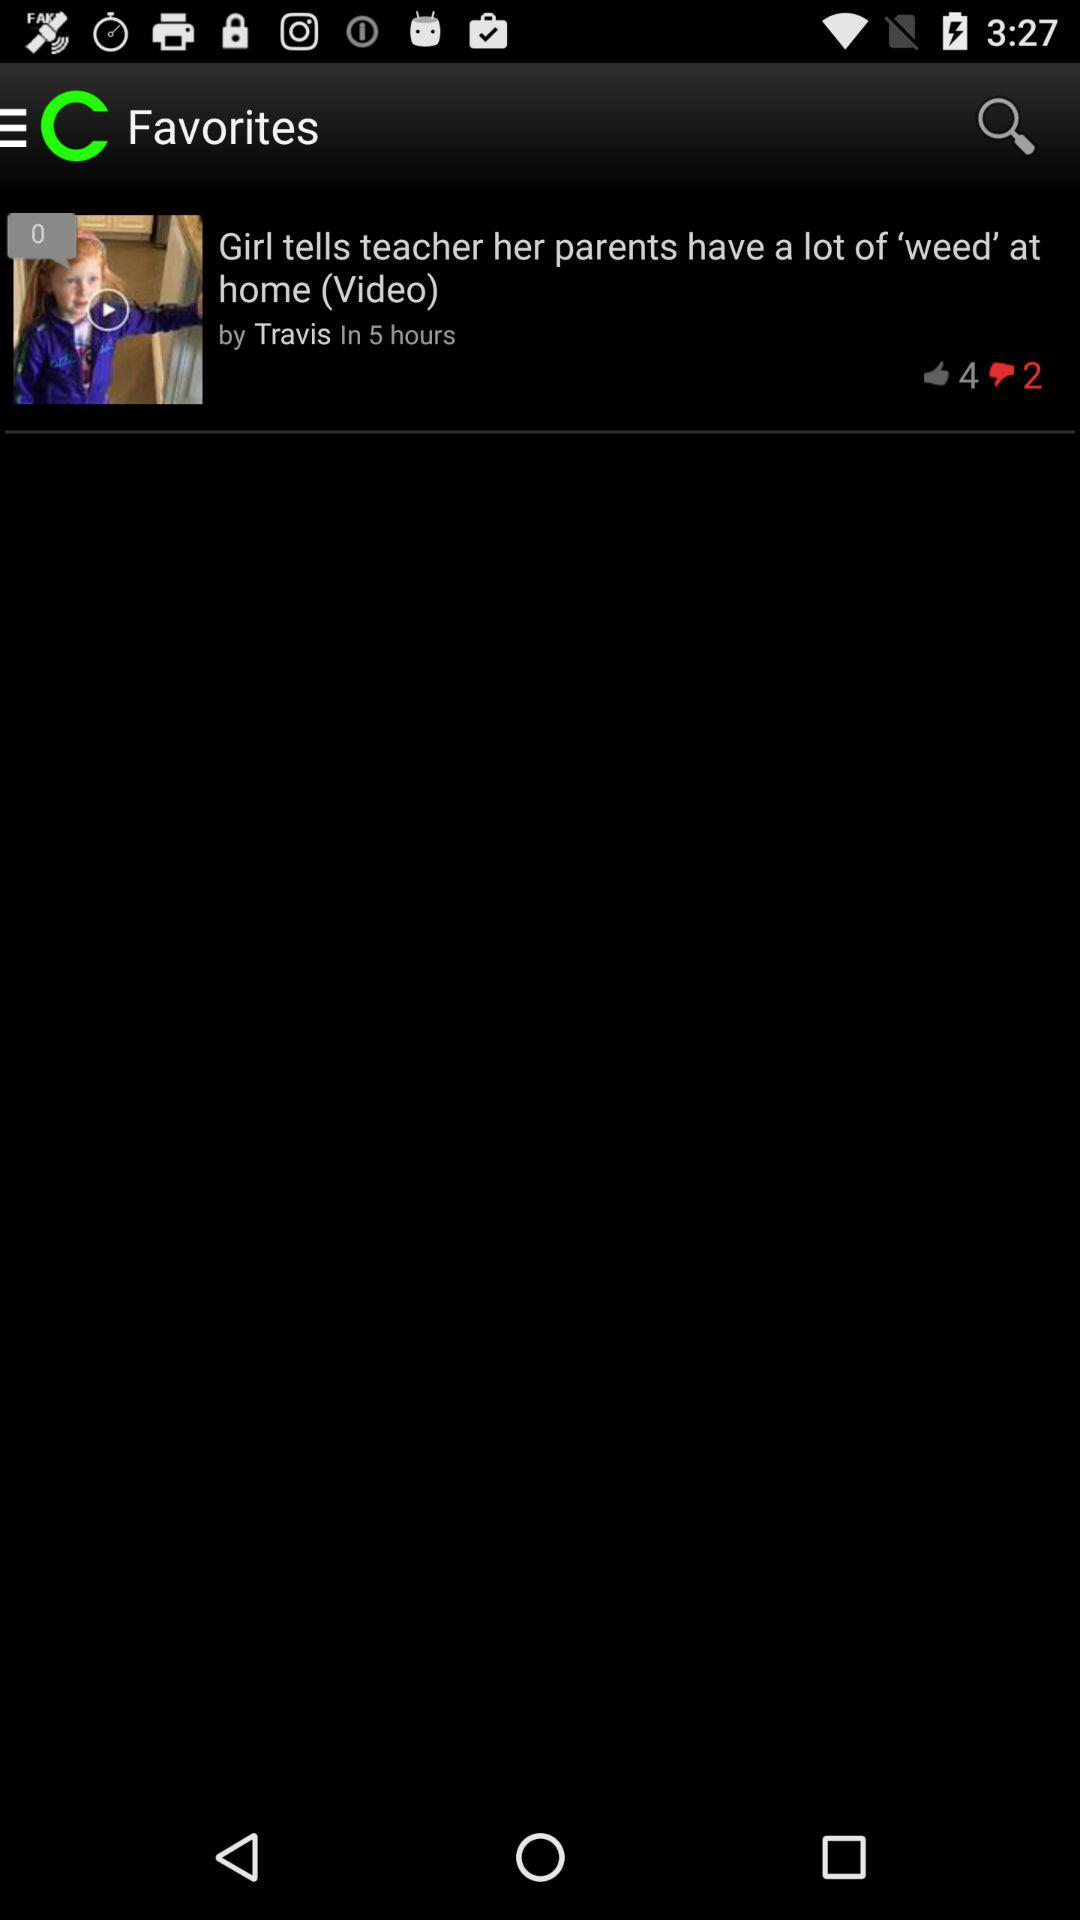How long is the video on the screen?
When the provided information is insufficient, respond with <no answer>. <no answer> 